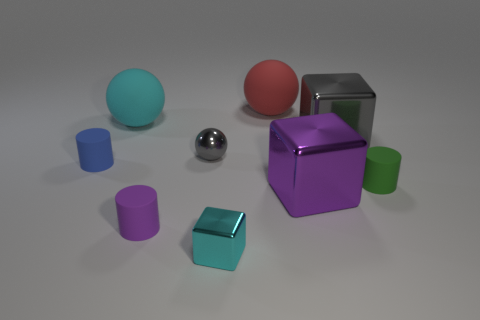What is the material of the large sphere that is the same color as the small block?
Your answer should be compact. Rubber. What number of cylinders are the same color as the tiny ball?
Ensure brevity in your answer.  0. How many things are either tiny matte cylinders that are on the right side of the purple matte thing or big spheres?
Ensure brevity in your answer.  3. There is a small cube that is the same material as the big gray thing; what is its color?
Your answer should be very brief. Cyan. Are there any green metallic objects of the same size as the blue matte cylinder?
Provide a succinct answer. No. How many objects are matte objects that are behind the blue rubber cylinder or balls in front of the large gray metallic thing?
Give a very brief answer. 3. The green matte thing that is the same size as the purple rubber cylinder is what shape?
Provide a succinct answer. Cylinder. Are there any large rubber things that have the same shape as the small gray shiny thing?
Provide a short and direct response. Yes. Is the number of large gray shiny blocks less than the number of red cubes?
Offer a terse response. No. Is the size of the cylinder to the right of the large red object the same as the block in front of the purple cylinder?
Offer a very short reply. Yes. 